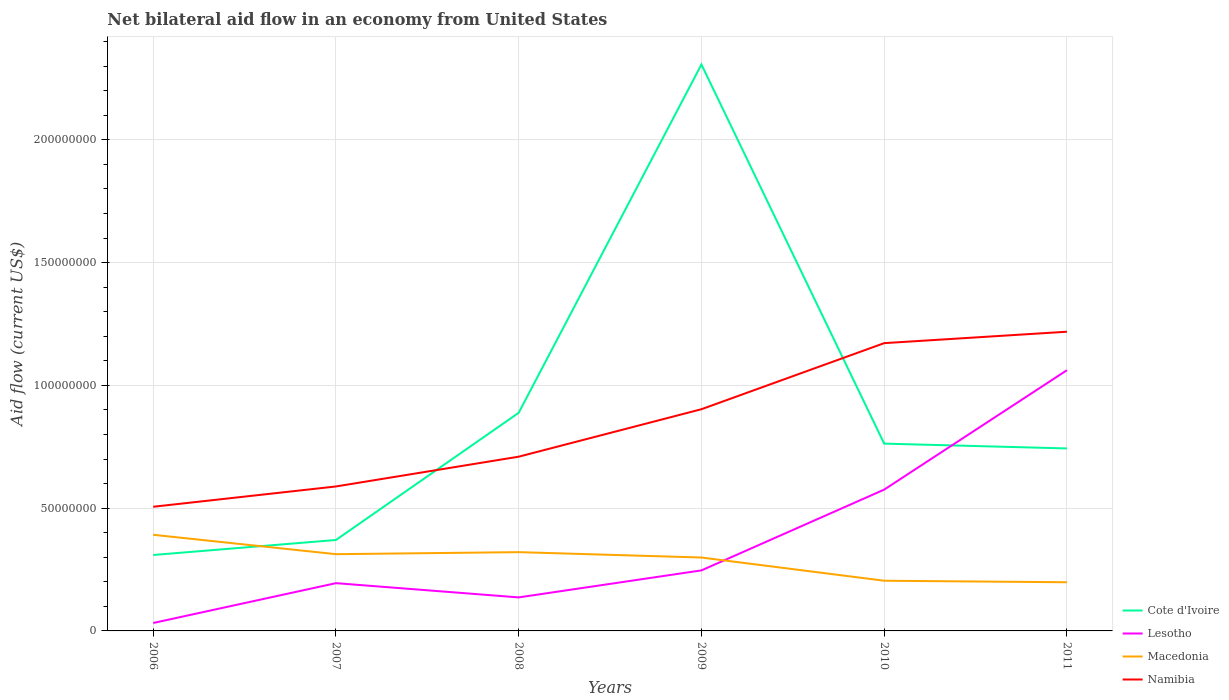Is the number of lines equal to the number of legend labels?
Your answer should be very brief. Yes. Across all years, what is the maximum net bilateral aid flow in Cote d'Ivoire?
Provide a succinct answer. 3.09e+07. In which year was the net bilateral aid flow in Macedonia maximum?
Ensure brevity in your answer.  2011. What is the total net bilateral aid flow in Macedonia in the graph?
Keep it short and to the point. 9.45e+06. What is the difference between the highest and the second highest net bilateral aid flow in Macedonia?
Your answer should be compact. 1.93e+07. Is the net bilateral aid flow in Cote d'Ivoire strictly greater than the net bilateral aid flow in Macedonia over the years?
Offer a terse response. No. Are the values on the major ticks of Y-axis written in scientific E-notation?
Keep it short and to the point. No. Does the graph contain grids?
Provide a succinct answer. Yes. Where does the legend appear in the graph?
Offer a very short reply. Bottom right. What is the title of the graph?
Ensure brevity in your answer.  Net bilateral aid flow in an economy from United States. What is the label or title of the X-axis?
Offer a terse response. Years. What is the Aid flow (current US$) in Cote d'Ivoire in 2006?
Provide a succinct answer. 3.09e+07. What is the Aid flow (current US$) in Lesotho in 2006?
Ensure brevity in your answer.  3.23e+06. What is the Aid flow (current US$) of Macedonia in 2006?
Provide a short and direct response. 3.92e+07. What is the Aid flow (current US$) of Namibia in 2006?
Offer a terse response. 5.06e+07. What is the Aid flow (current US$) in Cote d'Ivoire in 2007?
Your answer should be compact. 3.70e+07. What is the Aid flow (current US$) of Lesotho in 2007?
Provide a short and direct response. 1.94e+07. What is the Aid flow (current US$) in Macedonia in 2007?
Offer a very short reply. 3.12e+07. What is the Aid flow (current US$) of Namibia in 2007?
Make the answer very short. 5.88e+07. What is the Aid flow (current US$) in Cote d'Ivoire in 2008?
Keep it short and to the point. 8.88e+07. What is the Aid flow (current US$) in Lesotho in 2008?
Keep it short and to the point. 1.36e+07. What is the Aid flow (current US$) in Macedonia in 2008?
Your answer should be compact. 3.21e+07. What is the Aid flow (current US$) of Namibia in 2008?
Your answer should be very brief. 7.10e+07. What is the Aid flow (current US$) in Cote d'Ivoire in 2009?
Offer a terse response. 2.31e+08. What is the Aid flow (current US$) of Lesotho in 2009?
Provide a succinct answer. 2.46e+07. What is the Aid flow (current US$) of Macedonia in 2009?
Your answer should be very brief. 2.99e+07. What is the Aid flow (current US$) in Namibia in 2009?
Provide a succinct answer. 9.03e+07. What is the Aid flow (current US$) in Cote d'Ivoire in 2010?
Your response must be concise. 7.63e+07. What is the Aid flow (current US$) in Lesotho in 2010?
Your answer should be very brief. 5.75e+07. What is the Aid flow (current US$) of Macedonia in 2010?
Your answer should be very brief. 2.04e+07. What is the Aid flow (current US$) of Namibia in 2010?
Your response must be concise. 1.17e+08. What is the Aid flow (current US$) in Cote d'Ivoire in 2011?
Your answer should be compact. 7.43e+07. What is the Aid flow (current US$) of Lesotho in 2011?
Make the answer very short. 1.06e+08. What is the Aid flow (current US$) in Macedonia in 2011?
Give a very brief answer. 1.98e+07. What is the Aid flow (current US$) in Namibia in 2011?
Your answer should be compact. 1.22e+08. Across all years, what is the maximum Aid flow (current US$) of Cote d'Ivoire?
Provide a succinct answer. 2.31e+08. Across all years, what is the maximum Aid flow (current US$) in Lesotho?
Provide a succinct answer. 1.06e+08. Across all years, what is the maximum Aid flow (current US$) of Macedonia?
Your answer should be very brief. 3.92e+07. Across all years, what is the maximum Aid flow (current US$) of Namibia?
Provide a succinct answer. 1.22e+08. Across all years, what is the minimum Aid flow (current US$) of Cote d'Ivoire?
Your answer should be compact. 3.09e+07. Across all years, what is the minimum Aid flow (current US$) of Lesotho?
Offer a very short reply. 3.23e+06. Across all years, what is the minimum Aid flow (current US$) of Macedonia?
Ensure brevity in your answer.  1.98e+07. Across all years, what is the minimum Aid flow (current US$) of Namibia?
Keep it short and to the point. 5.06e+07. What is the total Aid flow (current US$) of Cote d'Ivoire in the graph?
Ensure brevity in your answer.  5.38e+08. What is the total Aid flow (current US$) of Lesotho in the graph?
Provide a succinct answer. 2.25e+08. What is the total Aid flow (current US$) in Macedonia in the graph?
Your response must be concise. 1.73e+08. What is the total Aid flow (current US$) of Namibia in the graph?
Keep it short and to the point. 5.10e+08. What is the difference between the Aid flow (current US$) of Cote d'Ivoire in 2006 and that in 2007?
Provide a succinct answer. -6.11e+06. What is the difference between the Aid flow (current US$) in Lesotho in 2006 and that in 2007?
Ensure brevity in your answer.  -1.62e+07. What is the difference between the Aid flow (current US$) in Macedonia in 2006 and that in 2007?
Provide a succinct answer. 7.90e+06. What is the difference between the Aid flow (current US$) of Namibia in 2006 and that in 2007?
Offer a very short reply. -8.27e+06. What is the difference between the Aid flow (current US$) in Cote d'Ivoire in 2006 and that in 2008?
Keep it short and to the point. -5.79e+07. What is the difference between the Aid flow (current US$) of Lesotho in 2006 and that in 2008?
Offer a terse response. -1.04e+07. What is the difference between the Aid flow (current US$) of Macedonia in 2006 and that in 2008?
Offer a very short reply. 7.07e+06. What is the difference between the Aid flow (current US$) of Namibia in 2006 and that in 2008?
Offer a very short reply. -2.04e+07. What is the difference between the Aid flow (current US$) of Cote d'Ivoire in 2006 and that in 2009?
Offer a very short reply. -2.00e+08. What is the difference between the Aid flow (current US$) of Lesotho in 2006 and that in 2009?
Offer a very short reply. -2.14e+07. What is the difference between the Aid flow (current US$) in Macedonia in 2006 and that in 2009?
Offer a terse response. 9.26e+06. What is the difference between the Aid flow (current US$) in Namibia in 2006 and that in 2009?
Ensure brevity in your answer.  -3.97e+07. What is the difference between the Aid flow (current US$) of Cote d'Ivoire in 2006 and that in 2010?
Your response must be concise. -4.54e+07. What is the difference between the Aid flow (current US$) in Lesotho in 2006 and that in 2010?
Offer a terse response. -5.43e+07. What is the difference between the Aid flow (current US$) in Macedonia in 2006 and that in 2010?
Your answer should be very brief. 1.87e+07. What is the difference between the Aid flow (current US$) of Namibia in 2006 and that in 2010?
Provide a short and direct response. -6.66e+07. What is the difference between the Aid flow (current US$) in Cote d'Ivoire in 2006 and that in 2011?
Offer a terse response. -4.34e+07. What is the difference between the Aid flow (current US$) in Lesotho in 2006 and that in 2011?
Make the answer very short. -1.03e+08. What is the difference between the Aid flow (current US$) in Macedonia in 2006 and that in 2011?
Offer a terse response. 1.93e+07. What is the difference between the Aid flow (current US$) of Namibia in 2006 and that in 2011?
Your response must be concise. -7.13e+07. What is the difference between the Aid flow (current US$) in Cote d'Ivoire in 2007 and that in 2008?
Your answer should be compact. -5.18e+07. What is the difference between the Aid flow (current US$) in Lesotho in 2007 and that in 2008?
Your answer should be compact. 5.80e+06. What is the difference between the Aid flow (current US$) of Macedonia in 2007 and that in 2008?
Offer a terse response. -8.30e+05. What is the difference between the Aid flow (current US$) in Namibia in 2007 and that in 2008?
Ensure brevity in your answer.  -1.21e+07. What is the difference between the Aid flow (current US$) of Cote d'Ivoire in 2007 and that in 2009?
Provide a succinct answer. -1.94e+08. What is the difference between the Aid flow (current US$) of Lesotho in 2007 and that in 2009?
Provide a short and direct response. -5.20e+06. What is the difference between the Aid flow (current US$) in Macedonia in 2007 and that in 2009?
Make the answer very short. 1.36e+06. What is the difference between the Aid flow (current US$) in Namibia in 2007 and that in 2009?
Give a very brief answer. -3.14e+07. What is the difference between the Aid flow (current US$) of Cote d'Ivoire in 2007 and that in 2010?
Your answer should be very brief. -3.92e+07. What is the difference between the Aid flow (current US$) of Lesotho in 2007 and that in 2010?
Provide a succinct answer. -3.81e+07. What is the difference between the Aid flow (current US$) of Macedonia in 2007 and that in 2010?
Ensure brevity in your answer.  1.08e+07. What is the difference between the Aid flow (current US$) of Namibia in 2007 and that in 2010?
Make the answer very short. -5.84e+07. What is the difference between the Aid flow (current US$) of Cote d'Ivoire in 2007 and that in 2011?
Offer a terse response. -3.73e+07. What is the difference between the Aid flow (current US$) in Lesotho in 2007 and that in 2011?
Provide a short and direct response. -8.67e+07. What is the difference between the Aid flow (current US$) of Macedonia in 2007 and that in 2011?
Your answer should be compact. 1.14e+07. What is the difference between the Aid flow (current US$) of Namibia in 2007 and that in 2011?
Offer a very short reply. -6.30e+07. What is the difference between the Aid flow (current US$) in Cote d'Ivoire in 2008 and that in 2009?
Give a very brief answer. -1.42e+08. What is the difference between the Aid flow (current US$) in Lesotho in 2008 and that in 2009?
Offer a terse response. -1.10e+07. What is the difference between the Aid flow (current US$) in Macedonia in 2008 and that in 2009?
Provide a short and direct response. 2.19e+06. What is the difference between the Aid flow (current US$) in Namibia in 2008 and that in 2009?
Offer a very short reply. -1.93e+07. What is the difference between the Aid flow (current US$) in Cote d'Ivoire in 2008 and that in 2010?
Provide a short and direct response. 1.26e+07. What is the difference between the Aid flow (current US$) of Lesotho in 2008 and that in 2010?
Your response must be concise. -4.39e+07. What is the difference between the Aid flow (current US$) in Macedonia in 2008 and that in 2010?
Offer a terse response. 1.16e+07. What is the difference between the Aid flow (current US$) of Namibia in 2008 and that in 2010?
Offer a terse response. -4.62e+07. What is the difference between the Aid flow (current US$) in Cote d'Ivoire in 2008 and that in 2011?
Your response must be concise. 1.45e+07. What is the difference between the Aid flow (current US$) in Lesotho in 2008 and that in 2011?
Make the answer very short. -9.25e+07. What is the difference between the Aid flow (current US$) in Macedonia in 2008 and that in 2011?
Provide a succinct answer. 1.23e+07. What is the difference between the Aid flow (current US$) in Namibia in 2008 and that in 2011?
Your response must be concise. -5.09e+07. What is the difference between the Aid flow (current US$) of Cote d'Ivoire in 2009 and that in 2010?
Provide a short and direct response. 1.54e+08. What is the difference between the Aid flow (current US$) in Lesotho in 2009 and that in 2010?
Make the answer very short. -3.29e+07. What is the difference between the Aid flow (current US$) of Macedonia in 2009 and that in 2010?
Keep it short and to the point. 9.45e+06. What is the difference between the Aid flow (current US$) of Namibia in 2009 and that in 2010?
Give a very brief answer. -2.69e+07. What is the difference between the Aid flow (current US$) of Cote d'Ivoire in 2009 and that in 2011?
Your answer should be compact. 1.56e+08. What is the difference between the Aid flow (current US$) in Lesotho in 2009 and that in 2011?
Your answer should be very brief. -8.15e+07. What is the difference between the Aid flow (current US$) in Macedonia in 2009 and that in 2011?
Your answer should be very brief. 1.01e+07. What is the difference between the Aid flow (current US$) of Namibia in 2009 and that in 2011?
Offer a terse response. -3.16e+07. What is the difference between the Aid flow (current US$) in Cote d'Ivoire in 2010 and that in 2011?
Your answer should be very brief. 1.96e+06. What is the difference between the Aid flow (current US$) in Lesotho in 2010 and that in 2011?
Your response must be concise. -4.86e+07. What is the difference between the Aid flow (current US$) of Macedonia in 2010 and that in 2011?
Provide a short and direct response. 6.20e+05. What is the difference between the Aid flow (current US$) in Namibia in 2010 and that in 2011?
Ensure brevity in your answer.  -4.65e+06. What is the difference between the Aid flow (current US$) of Cote d'Ivoire in 2006 and the Aid flow (current US$) of Lesotho in 2007?
Give a very brief answer. 1.15e+07. What is the difference between the Aid flow (current US$) of Cote d'Ivoire in 2006 and the Aid flow (current US$) of Macedonia in 2007?
Provide a succinct answer. -3.30e+05. What is the difference between the Aid flow (current US$) of Cote d'Ivoire in 2006 and the Aid flow (current US$) of Namibia in 2007?
Your response must be concise. -2.79e+07. What is the difference between the Aid flow (current US$) in Lesotho in 2006 and the Aid flow (current US$) in Macedonia in 2007?
Provide a short and direct response. -2.80e+07. What is the difference between the Aid flow (current US$) of Lesotho in 2006 and the Aid flow (current US$) of Namibia in 2007?
Your response must be concise. -5.56e+07. What is the difference between the Aid flow (current US$) in Macedonia in 2006 and the Aid flow (current US$) in Namibia in 2007?
Your response must be concise. -1.97e+07. What is the difference between the Aid flow (current US$) in Cote d'Ivoire in 2006 and the Aid flow (current US$) in Lesotho in 2008?
Your response must be concise. 1.73e+07. What is the difference between the Aid flow (current US$) of Cote d'Ivoire in 2006 and the Aid flow (current US$) of Macedonia in 2008?
Provide a succinct answer. -1.16e+06. What is the difference between the Aid flow (current US$) in Cote d'Ivoire in 2006 and the Aid flow (current US$) in Namibia in 2008?
Your answer should be very brief. -4.00e+07. What is the difference between the Aid flow (current US$) of Lesotho in 2006 and the Aid flow (current US$) of Macedonia in 2008?
Keep it short and to the point. -2.88e+07. What is the difference between the Aid flow (current US$) of Lesotho in 2006 and the Aid flow (current US$) of Namibia in 2008?
Your response must be concise. -6.77e+07. What is the difference between the Aid flow (current US$) in Macedonia in 2006 and the Aid flow (current US$) in Namibia in 2008?
Your answer should be very brief. -3.18e+07. What is the difference between the Aid flow (current US$) in Cote d'Ivoire in 2006 and the Aid flow (current US$) in Lesotho in 2009?
Your answer should be compact. 6.27e+06. What is the difference between the Aid flow (current US$) in Cote d'Ivoire in 2006 and the Aid flow (current US$) in Macedonia in 2009?
Provide a succinct answer. 1.03e+06. What is the difference between the Aid flow (current US$) of Cote d'Ivoire in 2006 and the Aid flow (current US$) of Namibia in 2009?
Your answer should be very brief. -5.94e+07. What is the difference between the Aid flow (current US$) of Lesotho in 2006 and the Aid flow (current US$) of Macedonia in 2009?
Your answer should be compact. -2.67e+07. What is the difference between the Aid flow (current US$) in Lesotho in 2006 and the Aid flow (current US$) in Namibia in 2009?
Your answer should be very brief. -8.70e+07. What is the difference between the Aid flow (current US$) in Macedonia in 2006 and the Aid flow (current US$) in Namibia in 2009?
Keep it short and to the point. -5.11e+07. What is the difference between the Aid flow (current US$) in Cote d'Ivoire in 2006 and the Aid flow (current US$) in Lesotho in 2010?
Provide a succinct answer. -2.66e+07. What is the difference between the Aid flow (current US$) of Cote d'Ivoire in 2006 and the Aid flow (current US$) of Macedonia in 2010?
Ensure brevity in your answer.  1.05e+07. What is the difference between the Aid flow (current US$) of Cote d'Ivoire in 2006 and the Aid flow (current US$) of Namibia in 2010?
Make the answer very short. -8.63e+07. What is the difference between the Aid flow (current US$) of Lesotho in 2006 and the Aid flow (current US$) of Macedonia in 2010?
Ensure brevity in your answer.  -1.72e+07. What is the difference between the Aid flow (current US$) in Lesotho in 2006 and the Aid flow (current US$) in Namibia in 2010?
Your response must be concise. -1.14e+08. What is the difference between the Aid flow (current US$) of Macedonia in 2006 and the Aid flow (current US$) of Namibia in 2010?
Ensure brevity in your answer.  -7.80e+07. What is the difference between the Aid flow (current US$) of Cote d'Ivoire in 2006 and the Aid flow (current US$) of Lesotho in 2011?
Ensure brevity in your answer.  -7.52e+07. What is the difference between the Aid flow (current US$) of Cote d'Ivoire in 2006 and the Aid flow (current US$) of Macedonia in 2011?
Make the answer very short. 1.11e+07. What is the difference between the Aid flow (current US$) in Cote d'Ivoire in 2006 and the Aid flow (current US$) in Namibia in 2011?
Provide a short and direct response. -9.09e+07. What is the difference between the Aid flow (current US$) in Lesotho in 2006 and the Aid flow (current US$) in Macedonia in 2011?
Make the answer very short. -1.66e+07. What is the difference between the Aid flow (current US$) in Lesotho in 2006 and the Aid flow (current US$) in Namibia in 2011?
Your answer should be compact. -1.19e+08. What is the difference between the Aid flow (current US$) of Macedonia in 2006 and the Aid flow (current US$) of Namibia in 2011?
Your answer should be compact. -8.27e+07. What is the difference between the Aid flow (current US$) of Cote d'Ivoire in 2007 and the Aid flow (current US$) of Lesotho in 2008?
Offer a terse response. 2.34e+07. What is the difference between the Aid flow (current US$) in Cote d'Ivoire in 2007 and the Aid flow (current US$) in Macedonia in 2008?
Ensure brevity in your answer.  4.95e+06. What is the difference between the Aid flow (current US$) in Cote d'Ivoire in 2007 and the Aid flow (current US$) in Namibia in 2008?
Provide a short and direct response. -3.39e+07. What is the difference between the Aid flow (current US$) in Lesotho in 2007 and the Aid flow (current US$) in Macedonia in 2008?
Offer a terse response. -1.26e+07. What is the difference between the Aid flow (current US$) of Lesotho in 2007 and the Aid flow (current US$) of Namibia in 2008?
Make the answer very short. -5.15e+07. What is the difference between the Aid flow (current US$) in Macedonia in 2007 and the Aid flow (current US$) in Namibia in 2008?
Offer a terse response. -3.97e+07. What is the difference between the Aid flow (current US$) in Cote d'Ivoire in 2007 and the Aid flow (current US$) in Lesotho in 2009?
Offer a very short reply. 1.24e+07. What is the difference between the Aid flow (current US$) of Cote d'Ivoire in 2007 and the Aid flow (current US$) of Macedonia in 2009?
Your answer should be very brief. 7.14e+06. What is the difference between the Aid flow (current US$) of Cote d'Ivoire in 2007 and the Aid flow (current US$) of Namibia in 2009?
Your answer should be very brief. -5.32e+07. What is the difference between the Aid flow (current US$) of Lesotho in 2007 and the Aid flow (current US$) of Macedonia in 2009?
Provide a succinct answer. -1.04e+07. What is the difference between the Aid flow (current US$) in Lesotho in 2007 and the Aid flow (current US$) in Namibia in 2009?
Keep it short and to the point. -7.08e+07. What is the difference between the Aid flow (current US$) of Macedonia in 2007 and the Aid flow (current US$) of Namibia in 2009?
Provide a succinct answer. -5.90e+07. What is the difference between the Aid flow (current US$) in Cote d'Ivoire in 2007 and the Aid flow (current US$) in Lesotho in 2010?
Your response must be concise. -2.05e+07. What is the difference between the Aid flow (current US$) of Cote d'Ivoire in 2007 and the Aid flow (current US$) of Macedonia in 2010?
Keep it short and to the point. 1.66e+07. What is the difference between the Aid flow (current US$) in Cote d'Ivoire in 2007 and the Aid flow (current US$) in Namibia in 2010?
Keep it short and to the point. -8.02e+07. What is the difference between the Aid flow (current US$) in Lesotho in 2007 and the Aid flow (current US$) in Macedonia in 2010?
Provide a short and direct response. -9.90e+05. What is the difference between the Aid flow (current US$) of Lesotho in 2007 and the Aid flow (current US$) of Namibia in 2010?
Offer a terse response. -9.77e+07. What is the difference between the Aid flow (current US$) of Macedonia in 2007 and the Aid flow (current US$) of Namibia in 2010?
Give a very brief answer. -8.59e+07. What is the difference between the Aid flow (current US$) of Cote d'Ivoire in 2007 and the Aid flow (current US$) of Lesotho in 2011?
Provide a short and direct response. -6.91e+07. What is the difference between the Aid flow (current US$) in Cote d'Ivoire in 2007 and the Aid flow (current US$) in Macedonia in 2011?
Your answer should be very brief. 1.72e+07. What is the difference between the Aid flow (current US$) in Cote d'Ivoire in 2007 and the Aid flow (current US$) in Namibia in 2011?
Your response must be concise. -8.48e+07. What is the difference between the Aid flow (current US$) of Lesotho in 2007 and the Aid flow (current US$) of Macedonia in 2011?
Offer a terse response. -3.70e+05. What is the difference between the Aid flow (current US$) in Lesotho in 2007 and the Aid flow (current US$) in Namibia in 2011?
Your response must be concise. -1.02e+08. What is the difference between the Aid flow (current US$) of Macedonia in 2007 and the Aid flow (current US$) of Namibia in 2011?
Your answer should be compact. -9.06e+07. What is the difference between the Aid flow (current US$) in Cote d'Ivoire in 2008 and the Aid flow (current US$) in Lesotho in 2009?
Keep it short and to the point. 6.42e+07. What is the difference between the Aid flow (current US$) of Cote d'Ivoire in 2008 and the Aid flow (current US$) of Macedonia in 2009?
Your answer should be very brief. 5.89e+07. What is the difference between the Aid flow (current US$) of Cote d'Ivoire in 2008 and the Aid flow (current US$) of Namibia in 2009?
Offer a very short reply. -1.46e+06. What is the difference between the Aid flow (current US$) of Lesotho in 2008 and the Aid flow (current US$) of Macedonia in 2009?
Provide a short and direct response. -1.62e+07. What is the difference between the Aid flow (current US$) of Lesotho in 2008 and the Aid flow (current US$) of Namibia in 2009?
Give a very brief answer. -7.66e+07. What is the difference between the Aid flow (current US$) of Macedonia in 2008 and the Aid flow (current US$) of Namibia in 2009?
Provide a succinct answer. -5.82e+07. What is the difference between the Aid flow (current US$) in Cote d'Ivoire in 2008 and the Aid flow (current US$) in Lesotho in 2010?
Your response must be concise. 3.13e+07. What is the difference between the Aid flow (current US$) in Cote d'Ivoire in 2008 and the Aid flow (current US$) in Macedonia in 2010?
Your answer should be compact. 6.84e+07. What is the difference between the Aid flow (current US$) in Cote d'Ivoire in 2008 and the Aid flow (current US$) in Namibia in 2010?
Your answer should be very brief. -2.84e+07. What is the difference between the Aid flow (current US$) in Lesotho in 2008 and the Aid flow (current US$) in Macedonia in 2010?
Provide a short and direct response. -6.79e+06. What is the difference between the Aid flow (current US$) in Lesotho in 2008 and the Aid flow (current US$) in Namibia in 2010?
Ensure brevity in your answer.  -1.04e+08. What is the difference between the Aid flow (current US$) in Macedonia in 2008 and the Aid flow (current US$) in Namibia in 2010?
Your response must be concise. -8.51e+07. What is the difference between the Aid flow (current US$) in Cote d'Ivoire in 2008 and the Aid flow (current US$) in Lesotho in 2011?
Offer a very short reply. -1.74e+07. What is the difference between the Aid flow (current US$) in Cote d'Ivoire in 2008 and the Aid flow (current US$) in Macedonia in 2011?
Provide a short and direct response. 6.90e+07. What is the difference between the Aid flow (current US$) in Cote d'Ivoire in 2008 and the Aid flow (current US$) in Namibia in 2011?
Your response must be concise. -3.30e+07. What is the difference between the Aid flow (current US$) in Lesotho in 2008 and the Aid flow (current US$) in Macedonia in 2011?
Offer a very short reply. -6.17e+06. What is the difference between the Aid flow (current US$) of Lesotho in 2008 and the Aid flow (current US$) of Namibia in 2011?
Offer a very short reply. -1.08e+08. What is the difference between the Aid flow (current US$) in Macedonia in 2008 and the Aid flow (current US$) in Namibia in 2011?
Provide a short and direct response. -8.98e+07. What is the difference between the Aid flow (current US$) of Cote d'Ivoire in 2009 and the Aid flow (current US$) of Lesotho in 2010?
Make the answer very short. 1.73e+08. What is the difference between the Aid flow (current US$) of Cote d'Ivoire in 2009 and the Aid flow (current US$) of Macedonia in 2010?
Offer a very short reply. 2.10e+08. What is the difference between the Aid flow (current US$) of Cote d'Ivoire in 2009 and the Aid flow (current US$) of Namibia in 2010?
Keep it short and to the point. 1.13e+08. What is the difference between the Aid flow (current US$) in Lesotho in 2009 and the Aid flow (current US$) in Macedonia in 2010?
Ensure brevity in your answer.  4.21e+06. What is the difference between the Aid flow (current US$) of Lesotho in 2009 and the Aid flow (current US$) of Namibia in 2010?
Ensure brevity in your answer.  -9.25e+07. What is the difference between the Aid flow (current US$) in Macedonia in 2009 and the Aid flow (current US$) in Namibia in 2010?
Make the answer very short. -8.73e+07. What is the difference between the Aid flow (current US$) of Cote d'Ivoire in 2009 and the Aid flow (current US$) of Lesotho in 2011?
Provide a short and direct response. 1.24e+08. What is the difference between the Aid flow (current US$) of Cote d'Ivoire in 2009 and the Aid flow (current US$) of Macedonia in 2011?
Your answer should be very brief. 2.11e+08. What is the difference between the Aid flow (current US$) of Cote d'Ivoire in 2009 and the Aid flow (current US$) of Namibia in 2011?
Give a very brief answer. 1.09e+08. What is the difference between the Aid flow (current US$) of Lesotho in 2009 and the Aid flow (current US$) of Macedonia in 2011?
Provide a short and direct response. 4.83e+06. What is the difference between the Aid flow (current US$) of Lesotho in 2009 and the Aid flow (current US$) of Namibia in 2011?
Make the answer very short. -9.72e+07. What is the difference between the Aid flow (current US$) of Macedonia in 2009 and the Aid flow (current US$) of Namibia in 2011?
Your answer should be compact. -9.20e+07. What is the difference between the Aid flow (current US$) of Cote d'Ivoire in 2010 and the Aid flow (current US$) of Lesotho in 2011?
Offer a terse response. -2.99e+07. What is the difference between the Aid flow (current US$) in Cote d'Ivoire in 2010 and the Aid flow (current US$) in Macedonia in 2011?
Keep it short and to the point. 5.64e+07. What is the difference between the Aid flow (current US$) of Cote d'Ivoire in 2010 and the Aid flow (current US$) of Namibia in 2011?
Your response must be concise. -4.56e+07. What is the difference between the Aid flow (current US$) in Lesotho in 2010 and the Aid flow (current US$) in Macedonia in 2011?
Your answer should be compact. 3.77e+07. What is the difference between the Aid flow (current US$) in Lesotho in 2010 and the Aid flow (current US$) in Namibia in 2011?
Provide a short and direct response. -6.43e+07. What is the difference between the Aid flow (current US$) in Macedonia in 2010 and the Aid flow (current US$) in Namibia in 2011?
Your answer should be compact. -1.01e+08. What is the average Aid flow (current US$) of Cote d'Ivoire per year?
Your response must be concise. 8.97e+07. What is the average Aid flow (current US$) in Lesotho per year?
Provide a succinct answer. 3.74e+07. What is the average Aid flow (current US$) in Macedonia per year?
Offer a terse response. 2.88e+07. What is the average Aid flow (current US$) of Namibia per year?
Ensure brevity in your answer.  8.49e+07. In the year 2006, what is the difference between the Aid flow (current US$) of Cote d'Ivoire and Aid flow (current US$) of Lesotho?
Offer a very short reply. 2.77e+07. In the year 2006, what is the difference between the Aid flow (current US$) in Cote d'Ivoire and Aid flow (current US$) in Macedonia?
Offer a terse response. -8.23e+06. In the year 2006, what is the difference between the Aid flow (current US$) of Cote d'Ivoire and Aid flow (current US$) of Namibia?
Give a very brief answer. -1.96e+07. In the year 2006, what is the difference between the Aid flow (current US$) of Lesotho and Aid flow (current US$) of Macedonia?
Give a very brief answer. -3.59e+07. In the year 2006, what is the difference between the Aid flow (current US$) of Lesotho and Aid flow (current US$) of Namibia?
Your answer should be compact. -4.73e+07. In the year 2006, what is the difference between the Aid flow (current US$) of Macedonia and Aid flow (current US$) of Namibia?
Your answer should be very brief. -1.14e+07. In the year 2007, what is the difference between the Aid flow (current US$) of Cote d'Ivoire and Aid flow (current US$) of Lesotho?
Keep it short and to the point. 1.76e+07. In the year 2007, what is the difference between the Aid flow (current US$) in Cote d'Ivoire and Aid flow (current US$) in Macedonia?
Your response must be concise. 5.78e+06. In the year 2007, what is the difference between the Aid flow (current US$) in Cote d'Ivoire and Aid flow (current US$) in Namibia?
Provide a succinct answer. -2.18e+07. In the year 2007, what is the difference between the Aid flow (current US$) of Lesotho and Aid flow (current US$) of Macedonia?
Make the answer very short. -1.18e+07. In the year 2007, what is the difference between the Aid flow (current US$) in Lesotho and Aid flow (current US$) in Namibia?
Your response must be concise. -3.94e+07. In the year 2007, what is the difference between the Aid flow (current US$) of Macedonia and Aid flow (current US$) of Namibia?
Provide a succinct answer. -2.76e+07. In the year 2008, what is the difference between the Aid flow (current US$) of Cote d'Ivoire and Aid flow (current US$) of Lesotho?
Offer a terse response. 7.52e+07. In the year 2008, what is the difference between the Aid flow (current US$) in Cote d'Ivoire and Aid flow (current US$) in Macedonia?
Ensure brevity in your answer.  5.67e+07. In the year 2008, what is the difference between the Aid flow (current US$) of Cote d'Ivoire and Aid flow (current US$) of Namibia?
Your answer should be compact. 1.79e+07. In the year 2008, what is the difference between the Aid flow (current US$) of Lesotho and Aid flow (current US$) of Macedonia?
Make the answer very short. -1.84e+07. In the year 2008, what is the difference between the Aid flow (current US$) in Lesotho and Aid flow (current US$) in Namibia?
Make the answer very short. -5.73e+07. In the year 2008, what is the difference between the Aid flow (current US$) of Macedonia and Aid flow (current US$) of Namibia?
Your response must be concise. -3.89e+07. In the year 2009, what is the difference between the Aid flow (current US$) of Cote d'Ivoire and Aid flow (current US$) of Lesotho?
Keep it short and to the point. 2.06e+08. In the year 2009, what is the difference between the Aid flow (current US$) in Cote d'Ivoire and Aid flow (current US$) in Macedonia?
Provide a succinct answer. 2.01e+08. In the year 2009, what is the difference between the Aid flow (current US$) of Cote d'Ivoire and Aid flow (current US$) of Namibia?
Offer a terse response. 1.40e+08. In the year 2009, what is the difference between the Aid flow (current US$) of Lesotho and Aid flow (current US$) of Macedonia?
Your answer should be compact. -5.24e+06. In the year 2009, what is the difference between the Aid flow (current US$) in Lesotho and Aid flow (current US$) in Namibia?
Offer a very short reply. -6.56e+07. In the year 2009, what is the difference between the Aid flow (current US$) in Macedonia and Aid flow (current US$) in Namibia?
Your answer should be very brief. -6.04e+07. In the year 2010, what is the difference between the Aid flow (current US$) in Cote d'Ivoire and Aid flow (current US$) in Lesotho?
Your response must be concise. 1.87e+07. In the year 2010, what is the difference between the Aid flow (current US$) of Cote d'Ivoire and Aid flow (current US$) of Macedonia?
Provide a succinct answer. 5.58e+07. In the year 2010, what is the difference between the Aid flow (current US$) in Cote d'Ivoire and Aid flow (current US$) in Namibia?
Your answer should be very brief. -4.09e+07. In the year 2010, what is the difference between the Aid flow (current US$) in Lesotho and Aid flow (current US$) in Macedonia?
Provide a succinct answer. 3.71e+07. In the year 2010, what is the difference between the Aid flow (current US$) of Lesotho and Aid flow (current US$) of Namibia?
Provide a short and direct response. -5.96e+07. In the year 2010, what is the difference between the Aid flow (current US$) in Macedonia and Aid flow (current US$) in Namibia?
Give a very brief answer. -9.68e+07. In the year 2011, what is the difference between the Aid flow (current US$) of Cote d'Ivoire and Aid flow (current US$) of Lesotho?
Ensure brevity in your answer.  -3.19e+07. In the year 2011, what is the difference between the Aid flow (current US$) of Cote d'Ivoire and Aid flow (current US$) of Macedonia?
Your answer should be very brief. 5.45e+07. In the year 2011, what is the difference between the Aid flow (current US$) in Cote d'Ivoire and Aid flow (current US$) in Namibia?
Ensure brevity in your answer.  -4.75e+07. In the year 2011, what is the difference between the Aid flow (current US$) in Lesotho and Aid flow (current US$) in Macedonia?
Give a very brief answer. 8.64e+07. In the year 2011, what is the difference between the Aid flow (current US$) of Lesotho and Aid flow (current US$) of Namibia?
Provide a succinct answer. -1.57e+07. In the year 2011, what is the difference between the Aid flow (current US$) in Macedonia and Aid flow (current US$) in Namibia?
Provide a short and direct response. -1.02e+08. What is the ratio of the Aid flow (current US$) of Cote d'Ivoire in 2006 to that in 2007?
Keep it short and to the point. 0.83. What is the ratio of the Aid flow (current US$) of Lesotho in 2006 to that in 2007?
Ensure brevity in your answer.  0.17. What is the ratio of the Aid flow (current US$) of Macedonia in 2006 to that in 2007?
Keep it short and to the point. 1.25. What is the ratio of the Aid flow (current US$) of Namibia in 2006 to that in 2007?
Your response must be concise. 0.86. What is the ratio of the Aid flow (current US$) of Cote d'Ivoire in 2006 to that in 2008?
Make the answer very short. 0.35. What is the ratio of the Aid flow (current US$) in Lesotho in 2006 to that in 2008?
Ensure brevity in your answer.  0.24. What is the ratio of the Aid flow (current US$) of Macedonia in 2006 to that in 2008?
Make the answer very short. 1.22. What is the ratio of the Aid flow (current US$) in Namibia in 2006 to that in 2008?
Keep it short and to the point. 0.71. What is the ratio of the Aid flow (current US$) in Cote d'Ivoire in 2006 to that in 2009?
Ensure brevity in your answer.  0.13. What is the ratio of the Aid flow (current US$) in Lesotho in 2006 to that in 2009?
Provide a short and direct response. 0.13. What is the ratio of the Aid flow (current US$) in Macedonia in 2006 to that in 2009?
Your answer should be compact. 1.31. What is the ratio of the Aid flow (current US$) of Namibia in 2006 to that in 2009?
Your answer should be compact. 0.56. What is the ratio of the Aid flow (current US$) in Cote d'Ivoire in 2006 to that in 2010?
Provide a short and direct response. 0.41. What is the ratio of the Aid flow (current US$) in Lesotho in 2006 to that in 2010?
Ensure brevity in your answer.  0.06. What is the ratio of the Aid flow (current US$) of Macedonia in 2006 to that in 2010?
Your response must be concise. 1.92. What is the ratio of the Aid flow (current US$) of Namibia in 2006 to that in 2010?
Keep it short and to the point. 0.43. What is the ratio of the Aid flow (current US$) in Cote d'Ivoire in 2006 to that in 2011?
Provide a succinct answer. 0.42. What is the ratio of the Aid flow (current US$) in Lesotho in 2006 to that in 2011?
Your answer should be compact. 0.03. What is the ratio of the Aid flow (current US$) in Macedonia in 2006 to that in 2011?
Keep it short and to the point. 1.98. What is the ratio of the Aid flow (current US$) in Namibia in 2006 to that in 2011?
Provide a short and direct response. 0.41. What is the ratio of the Aid flow (current US$) in Cote d'Ivoire in 2007 to that in 2008?
Provide a short and direct response. 0.42. What is the ratio of the Aid flow (current US$) in Lesotho in 2007 to that in 2008?
Offer a terse response. 1.42. What is the ratio of the Aid flow (current US$) of Macedonia in 2007 to that in 2008?
Make the answer very short. 0.97. What is the ratio of the Aid flow (current US$) in Namibia in 2007 to that in 2008?
Give a very brief answer. 0.83. What is the ratio of the Aid flow (current US$) of Cote d'Ivoire in 2007 to that in 2009?
Your answer should be very brief. 0.16. What is the ratio of the Aid flow (current US$) in Lesotho in 2007 to that in 2009?
Your answer should be compact. 0.79. What is the ratio of the Aid flow (current US$) of Macedonia in 2007 to that in 2009?
Keep it short and to the point. 1.05. What is the ratio of the Aid flow (current US$) of Namibia in 2007 to that in 2009?
Keep it short and to the point. 0.65. What is the ratio of the Aid flow (current US$) of Cote d'Ivoire in 2007 to that in 2010?
Make the answer very short. 0.49. What is the ratio of the Aid flow (current US$) of Lesotho in 2007 to that in 2010?
Ensure brevity in your answer.  0.34. What is the ratio of the Aid flow (current US$) in Macedonia in 2007 to that in 2010?
Provide a short and direct response. 1.53. What is the ratio of the Aid flow (current US$) in Namibia in 2007 to that in 2010?
Give a very brief answer. 0.5. What is the ratio of the Aid flow (current US$) in Cote d'Ivoire in 2007 to that in 2011?
Provide a succinct answer. 0.5. What is the ratio of the Aid flow (current US$) in Lesotho in 2007 to that in 2011?
Your answer should be compact. 0.18. What is the ratio of the Aid flow (current US$) in Macedonia in 2007 to that in 2011?
Offer a very short reply. 1.58. What is the ratio of the Aid flow (current US$) in Namibia in 2007 to that in 2011?
Provide a short and direct response. 0.48. What is the ratio of the Aid flow (current US$) of Cote d'Ivoire in 2008 to that in 2009?
Offer a very short reply. 0.39. What is the ratio of the Aid flow (current US$) in Lesotho in 2008 to that in 2009?
Your answer should be very brief. 0.55. What is the ratio of the Aid flow (current US$) of Macedonia in 2008 to that in 2009?
Keep it short and to the point. 1.07. What is the ratio of the Aid flow (current US$) in Namibia in 2008 to that in 2009?
Offer a terse response. 0.79. What is the ratio of the Aid flow (current US$) of Cote d'Ivoire in 2008 to that in 2010?
Offer a terse response. 1.16. What is the ratio of the Aid flow (current US$) of Lesotho in 2008 to that in 2010?
Provide a succinct answer. 0.24. What is the ratio of the Aid flow (current US$) of Macedonia in 2008 to that in 2010?
Your answer should be very brief. 1.57. What is the ratio of the Aid flow (current US$) of Namibia in 2008 to that in 2010?
Provide a succinct answer. 0.61. What is the ratio of the Aid flow (current US$) of Cote d'Ivoire in 2008 to that in 2011?
Keep it short and to the point. 1.2. What is the ratio of the Aid flow (current US$) in Lesotho in 2008 to that in 2011?
Ensure brevity in your answer.  0.13. What is the ratio of the Aid flow (current US$) in Macedonia in 2008 to that in 2011?
Provide a short and direct response. 1.62. What is the ratio of the Aid flow (current US$) of Namibia in 2008 to that in 2011?
Your answer should be compact. 0.58. What is the ratio of the Aid flow (current US$) in Cote d'Ivoire in 2009 to that in 2010?
Your answer should be compact. 3.02. What is the ratio of the Aid flow (current US$) in Lesotho in 2009 to that in 2010?
Your answer should be compact. 0.43. What is the ratio of the Aid flow (current US$) in Macedonia in 2009 to that in 2010?
Make the answer very short. 1.46. What is the ratio of the Aid flow (current US$) of Namibia in 2009 to that in 2010?
Your response must be concise. 0.77. What is the ratio of the Aid flow (current US$) of Cote d'Ivoire in 2009 to that in 2011?
Keep it short and to the point. 3.1. What is the ratio of the Aid flow (current US$) of Lesotho in 2009 to that in 2011?
Your answer should be very brief. 0.23. What is the ratio of the Aid flow (current US$) of Macedonia in 2009 to that in 2011?
Provide a succinct answer. 1.51. What is the ratio of the Aid flow (current US$) in Namibia in 2009 to that in 2011?
Provide a short and direct response. 0.74. What is the ratio of the Aid flow (current US$) of Cote d'Ivoire in 2010 to that in 2011?
Offer a terse response. 1.03. What is the ratio of the Aid flow (current US$) in Lesotho in 2010 to that in 2011?
Your response must be concise. 0.54. What is the ratio of the Aid flow (current US$) in Macedonia in 2010 to that in 2011?
Offer a terse response. 1.03. What is the ratio of the Aid flow (current US$) of Namibia in 2010 to that in 2011?
Ensure brevity in your answer.  0.96. What is the difference between the highest and the second highest Aid flow (current US$) in Cote d'Ivoire?
Your response must be concise. 1.42e+08. What is the difference between the highest and the second highest Aid flow (current US$) in Lesotho?
Your answer should be very brief. 4.86e+07. What is the difference between the highest and the second highest Aid flow (current US$) of Macedonia?
Ensure brevity in your answer.  7.07e+06. What is the difference between the highest and the second highest Aid flow (current US$) in Namibia?
Provide a succinct answer. 4.65e+06. What is the difference between the highest and the lowest Aid flow (current US$) of Cote d'Ivoire?
Provide a succinct answer. 2.00e+08. What is the difference between the highest and the lowest Aid flow (current US$) of Lesotho?
Keep it short and to the point. 1.03e+08. What is the difference between the highest and the lowest Aid flow (current US$) of Macedonia?
Ensure brevity in your answer.  1.93e+07. What is the difference between the highest and the lowest Aid flow (current US$) of Namibia?
Your response must be concise. 7.13e+07. 